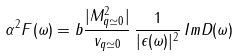<formula> <loc_0><loc_0><loc_500><loc_500>\alpha ^ { 2 } F ( \omega ) = b \frac { | M ^ { 2 } _ { q \simeq 0 } | } { v _ { q \simeq 0 } } \, \frac { 1 } { | \epsilon ( \omega ) | ^ { 2 } } \, I m D ( \omega )</formula> 